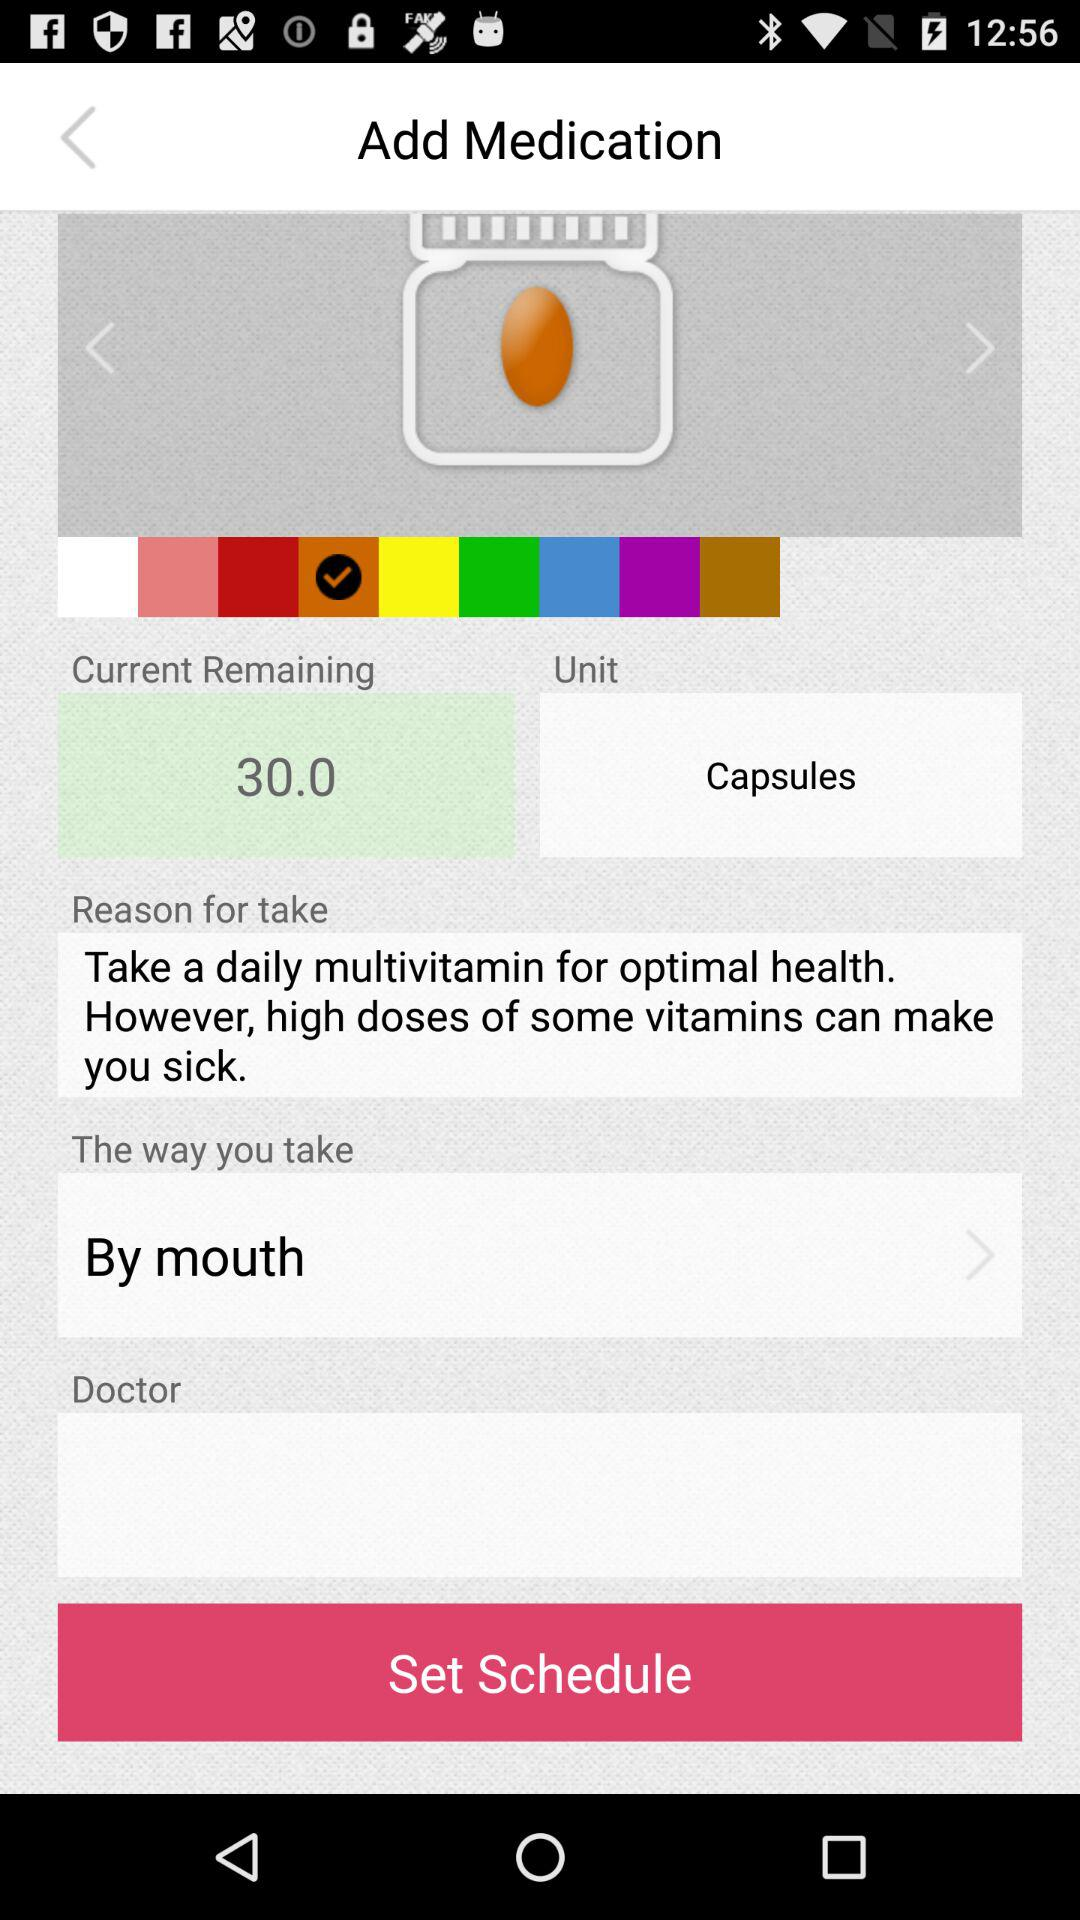How many capsules are currently remaining? The current number of remaining capsules is 30. 